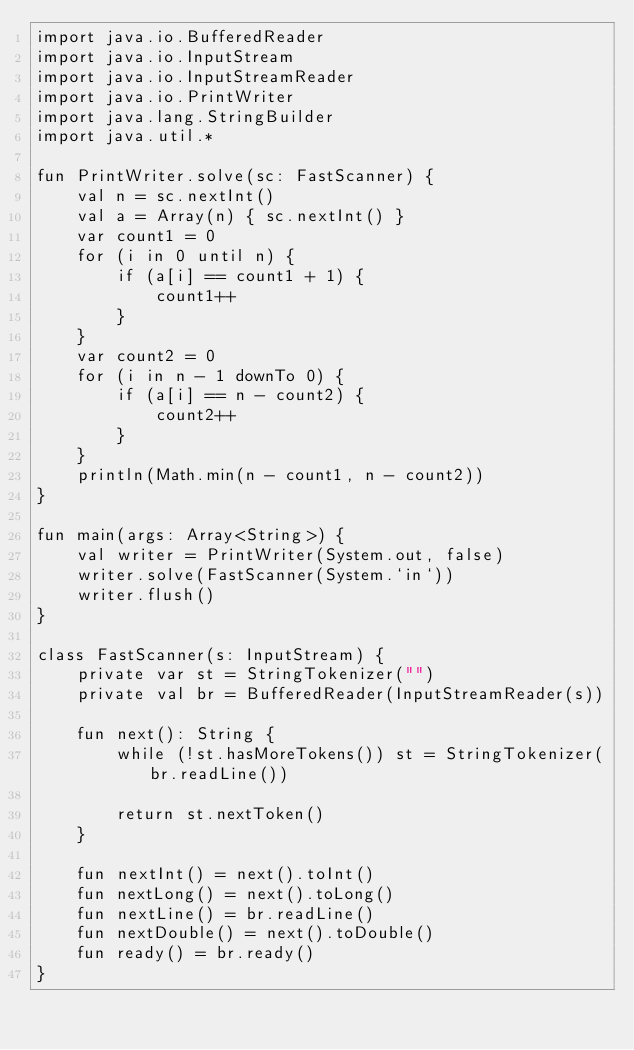<code> <loc_0><loc_0><loc_500><loc_500><_Kotlin_>import java.io.BufferedReader
import java.io.InputStream
import java.io.InputStreamReader
import java.io.PrintWriter
import java.lang.StringBuilder
import java.util.*

fun PrintWriter.solve(sc: FastScanner) {
    val n = sc.nextInt()
    val a = Array(n) { sc.nextInt() }
    var count1 = 0
    for (i in 0 until n) {
        if (a[i] == count1 + 1) {
            count1++
        }
    }
    var count2 = 0
    for (i in n - 1 downTo 0) {
        if (a[i] == n - count2) {
            count2++
        }
    }
    println(Math.min(n - count1, n - count2))
}

fun main(args: Array<String>) {
    val writer = PrintWriter(System.out, false)
    writer.solve(FastScanner(System.`in`))
    writer.flush()
}

class FastScanner(s: InputStream) {
    private var st = StringTokenizer("")
    private val br = BufferedReader(InputStreamReader(s))

    fun next(): String {
        while (!st.hasMoreTokens()) st = StringTokenizer(br.readLine())

        return st.nextToken()
    }

    fun nextInt() = next().toInt()
    fun nextLong() = next().toLong()
    fun nextLine() = br.readLine()
    fun nextDouble() = next().toDouble()
    fun ready() = br.ready()
}
</code> 